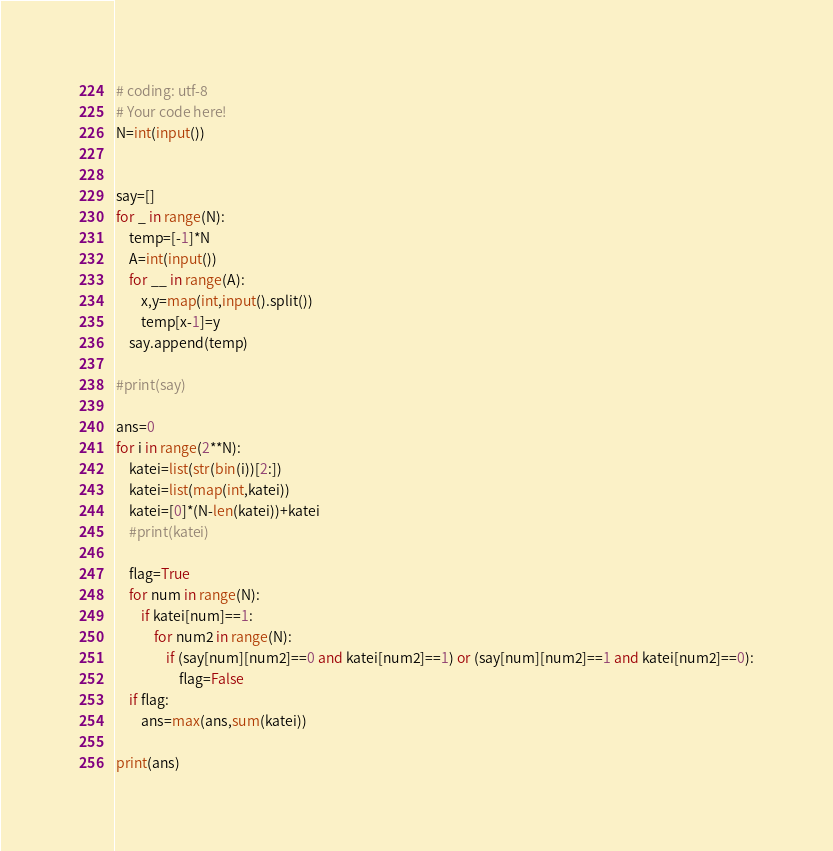<code> <loc_0><loc_0><loc_500><loc_500><_Python_># coding: utf-8
# Your code here!
N=int(input())


say=[]
for _ in range(N):
    temp=[-1]*N
    A=int(input())
    for __ in range(A):
        x,y=map(int,input().split())
        temp[x-1]=y
    say.append(temp)

#print(say)

ans=0
for i in range(2**N):
    katei=list(str(bin(i))[2:])
    katei=list(map(int,katei))
    katei=[0]*(N-len(katei))+katei
    #print(katei)
    
    flag=True
    for num in range(N):
        if katei[num]==1:
            for num2 in range(N):
                if (say[num][num2]==0 and katei[num2]==1) or (say[num][num2]==1 and katei[num2]==0):
                    flag=False
    if flag:
        ans=max(ans,sum(katei))
    
print(ans)
</code> 